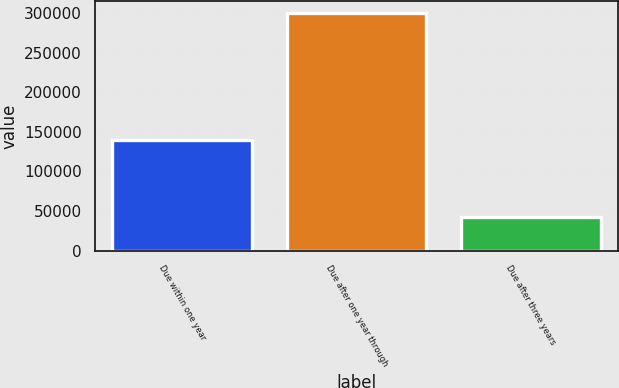Convert chart to OTSL. <chart><loc_0><loc_0><loc_500><loc_500><bar_chart><fcel>Due within one year<fcel>Due after one year through<fcel>Due after three years<nl><fcel>139386<fcel>300021<fcel>42147<nl></chart> 